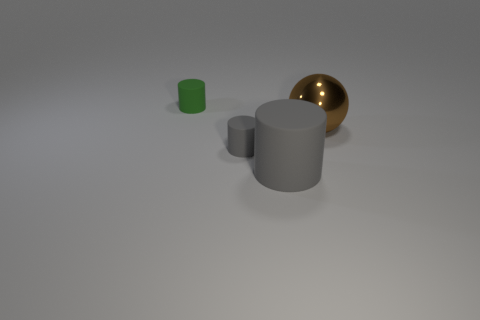Subtract all green cylinders. How many cylinders are left? 2 Add 1 red blocks. How many objects exist? 5 Subtract all red cubes. How many gray cylinders are left? 2 Subtract 1 cylinders. How many cylinders are left? 2 Subtract all green cylinders. How many cylinders are left? 2 Subtract all balls. How many objects are left? 3 Subtract all cyan cylinders. Subtract all green cubes. How many cylinders are left? 3 Subtract all brown metallic spheres. Subtract all small gray cylinders. How many objects are left? 2 Add 2 large brown spheres. How many large brown spheres are left? 3 Add 2 gray cylinders. How many gray cylinders exist? 4 